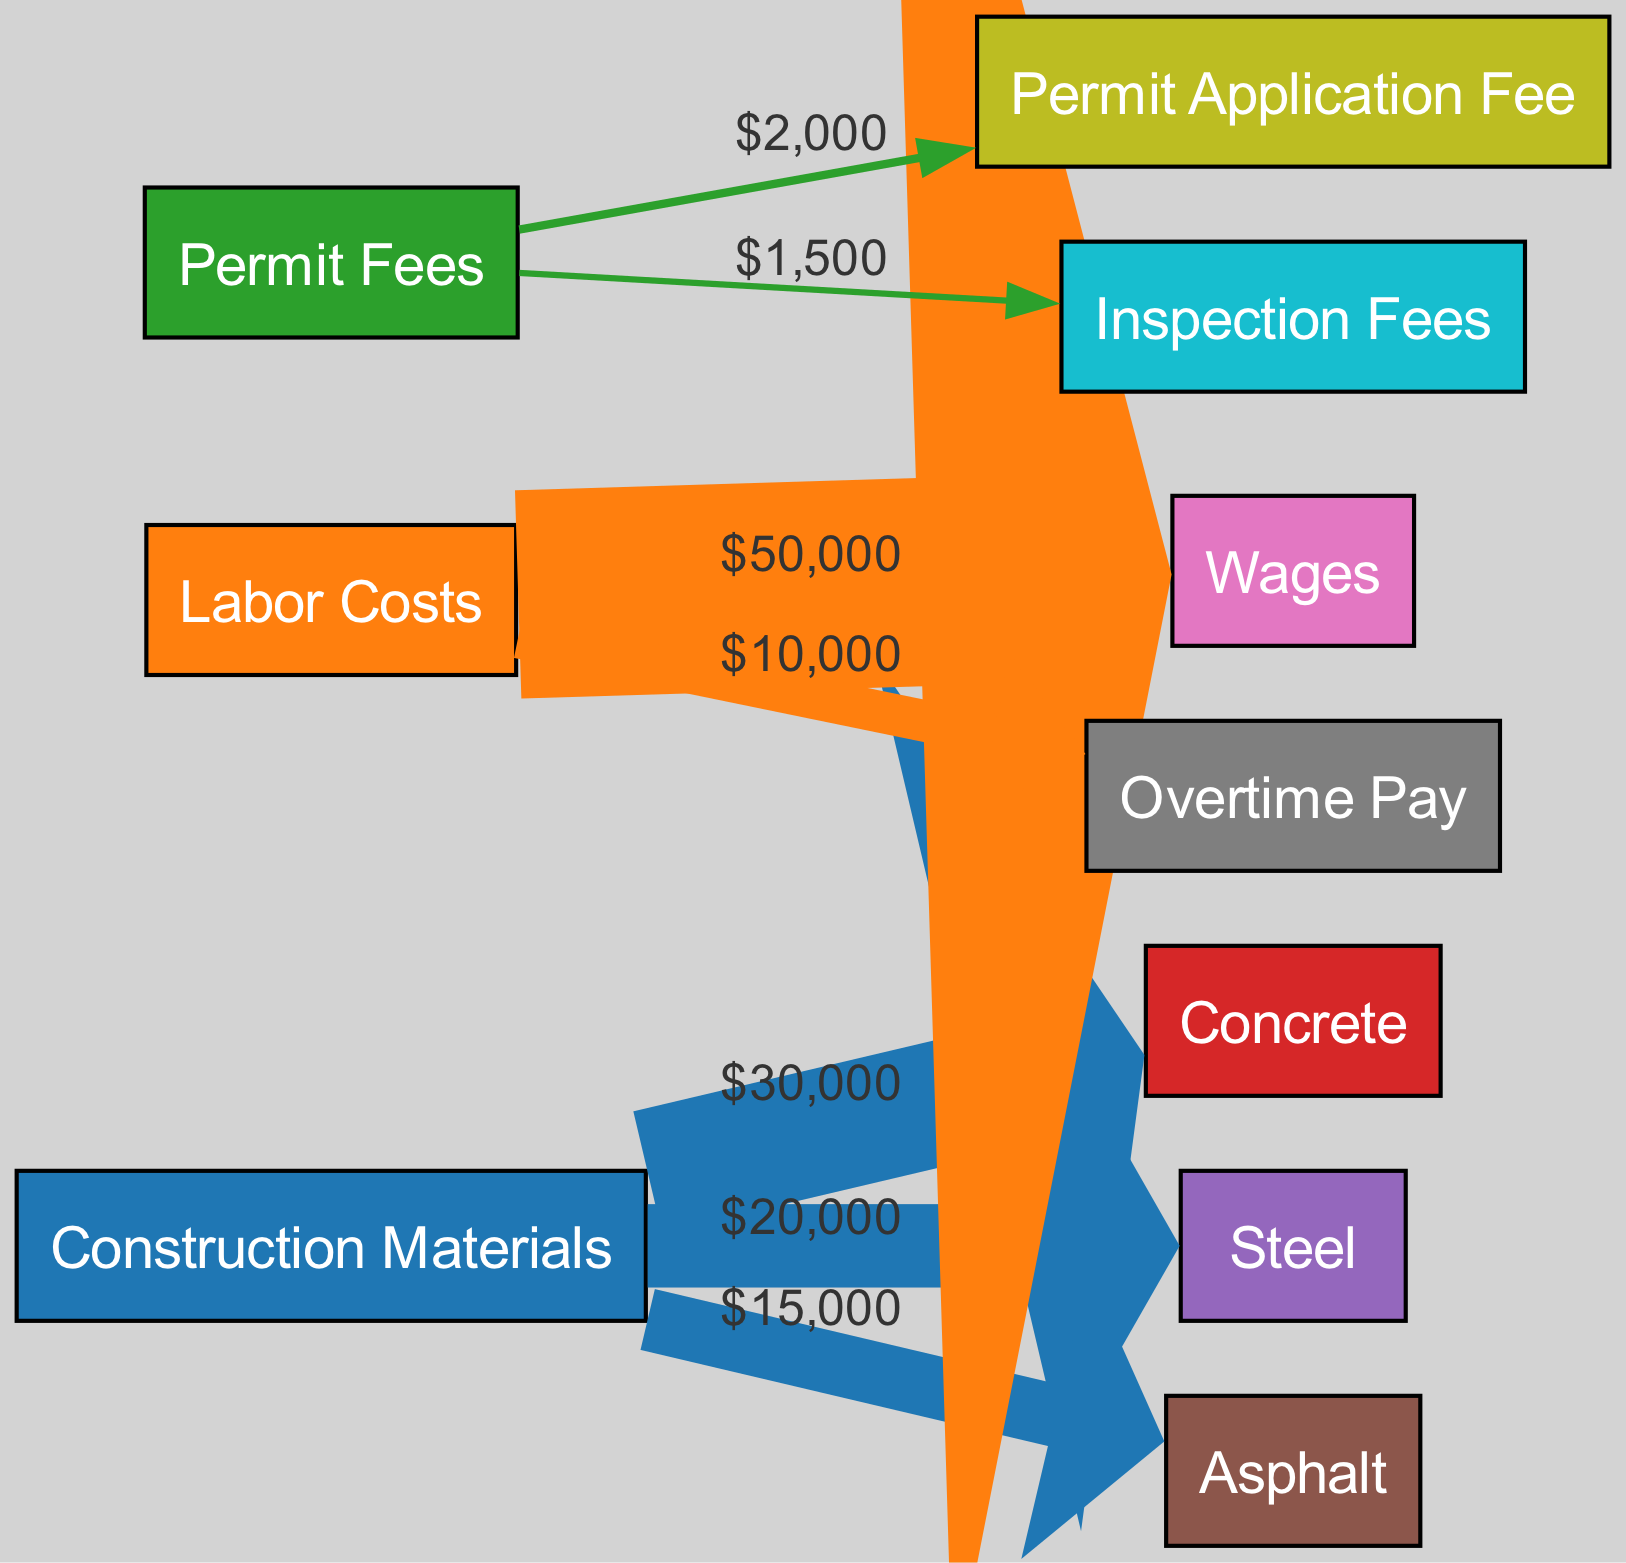What is the total cost of Concrete? The diagram shows a direct link from the "Construction Materials" node to the "Concrete" node labeled with a value. The value of the edge from "Materials" to "Concrete" is $30,000.
Answer: 30,000 What are the two categories of Labor Costs represented? From the "Labor Costs" node, two edges lead to the "Wages" and "Overtime" nodes. The edges represent different types of labor expenses.
Answer: Wages and Overtime How much is spent on Permit Application Fees? The diagram indicates an edge from the "Permits" node to the "Permit Application" node, labeled with the amount. This edge shows that the Permit Application Fee is $2,000.
Answer: 2,000 How much is the total spent on materials? To find the total material cost, sum the values from the "Materials" node: 30,000 (Concrete) + 20,000 (Steel) + 15,000 (Asphalt). This gives a total of $65,000 for construction materials.
Answer: 65,000 Which type of construction material has the lowest expense? Comparing the edge values from the "Materials" node, Concrete ($30,000), Steel ($20,000), and Asphalt ($15,000). Asphalt has the lowest expense, making it the cheapest material.
Answer: Asphalt What percentage of total costs is spent on Labor? First, calculate total costs by adding all values from the diagram: 30,000 (Concrete) + 20,000 (Steel) + 15,000 (Asphalt) + 50,000 (Wages) + 10,000 (Overtime) + 2,000 (Permit Application) + 1,500 (Inspection) = $128,500. The total spent on Labor is $60,000. Therefore, (60,000/128,500) * 100 = 46.7%.
Answer: 46.7% Which node represents the highest individual expense? By reviewing the edges, the highest value is linked from the "Labor" node to the "Wages" node, showing a value of $50,000, which is greater than other individual expenses.
Answer: Wages What is the total amount of Permit Fees? The total permit costs can be found by adding the values for the two edges leading from the "Permits" node: 2,000 (Permit Application) + 1,500 (Inspection) = $3,500.
Answer: 3,500 How many nodes are there in the diagram? Counting all the distinct nodes listed in the diagram: Construction Materials, Labor Costs, Permit Fees, Concrete, Steel, Asphalt, Wages, Overtime, Permit Application Fee, and Inspection Fees gives a total of 10 nodes.
Answer: 10 